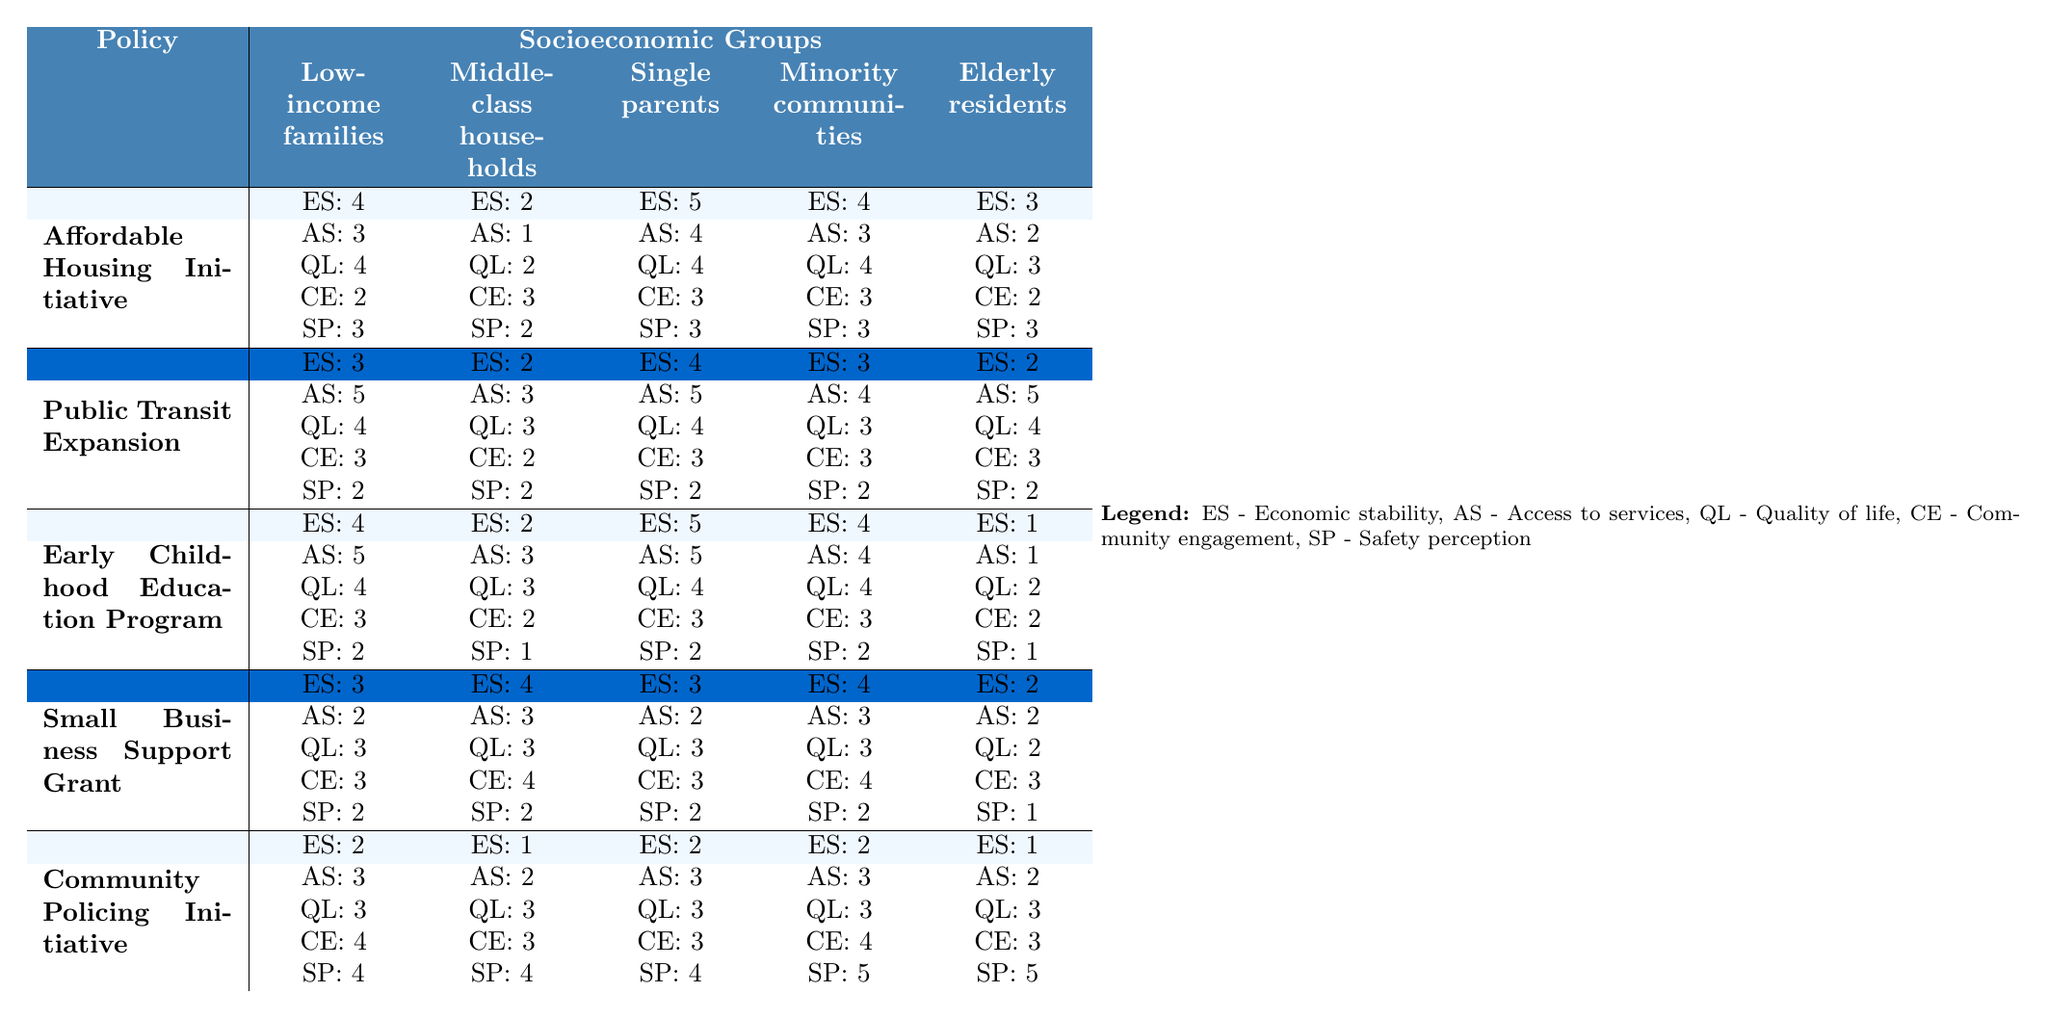What is the economic stability rating for single parents under the Affordable Housing Initiative? The table shows that the economic stability rating (ES) for single parents under the Affordable Housing Initiative is 5.
Answer: 5 Which socioeconomic group has the highest quality of life rating for the Public Transit Expansion policy? The quality of life rating (QL) for single parents under Public Transit Expansion is 4, which is higher than the others (Low-income families: 4, Middle-class households: 3, Minority communities: 3, Elderly residents: 4), making them the group with the highest rating.
Answer: Single parents What is the safety perception score for elderly residents under the Community Policing Initiative? The table indicates that the safety perception score (SP) for elderly residents under the Community Policing Initiative is 5.
Answer: 5 What is the average economic stability rating across all groups for the Early Childhood Education Program? The economic stability ratings are 4 (Low-income families), 2 (Middle-class households), 5 (Single parents), 4 (Minority communities), and 1 (Elderly residents). Adding them gives 16, which when divided by 5 results in an average of 3.2.
Answer: 3.2 Is the access to services rating for minority communities lower than that of middle-class households under the Small Business Support Grant? The access to services rating (AS) is 3 for both minority communities and middle-class households, so the statement is false; both groups have the same rating.
Answer: No What policy shows the greatest improvement in access to services for low-income families? Access to services for low-income families is rated at 5 under the Public Transit Expansion, which is higher than all other policies (Affordable Housing Initiative: 3, Early Childhood Education Program: 5, Small Business Support Grant: 2, Community Policing Initiative: 3). Hence, the Public Transit Expansion shows the greatest improvement.
Answer: Public Transit Expansion Under which policy does the elderly community have the lowest access to services rating? The table indicates that the elderly residents have the lowest access to services rating (AS) of 1 under the Early Childhood Education Program compared to the other policies (Affordable Housing Initiative: 2, Public Transit Expansion: 5, Small Business Support Grant: 2, Community Policing Initiative: 2).
Answer: Early Childhood Education Program What are the combined safety perception scores for low-income families across all policies? The safety perception scores for low-income families are 3 (Affordable Housing Initiative), 2 (Public Transit Expansion), 2 (Early Childhood Education Program), 2 (Small Business Support Grant), and 4 (Community Policing Initiative). Summing these gives 3 + 2 + 2 + 2 + 4 = 13.
Answer: 13 Which socioeconomic group benefits most in terms of safety perception from the Community Policing Initiative? The safety perception score for minority communities under the Community Policing Initiative is 5, which is the highest score compared to the other groups (Low-income families: 4, Middle-class households: 4, Single parents: 4, Elderly residents: 5).
Answer: Minority communities and elderly residents (tied) Is there any socioeconomic group that experienced a drop in economic stability ratings from the Affordable Housing Initiative to the Public Transit Expansion policy? Yes, the economic stability rating of middle-class households dropped from 2 under the Affordable Housing Initiative to 2 under the Public Transit Expansion (the rating remained the same). However, low-income families dropped from 4 to 3, and elderly residents dropped from 3 to 2.
Answer: Yes, low-income families and elderly residents experienced a drop 